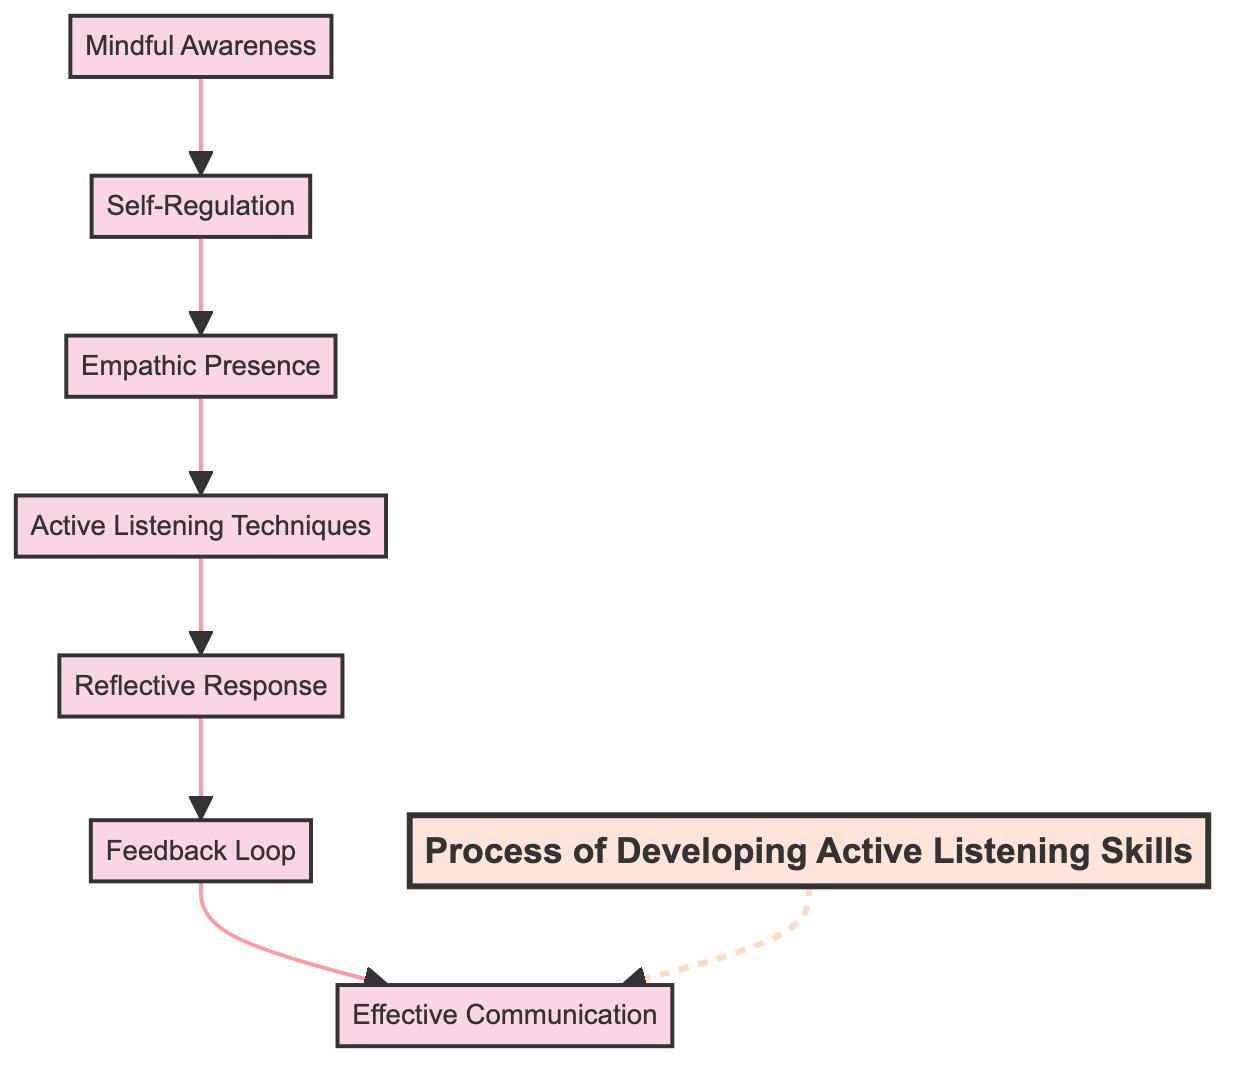What is the starting point of the process? The starting point is "Mindful Awareness," which is the first step in the flowchart.
Answer: Mindful Awareness How many steps are there in the process? There are seven steps depicted in the diagram, ranging from "Mindful Awareness" to "Effective Communication."
Answer: 7 What comes immediately after "Self-Regulation"? The step that comes immediately after "Self-Regulation" is "Empathic Presence."
Answer: Empathic Presence Which step involves reflecting back what the speaker has said? The step involving reflecting back is "Reflective Response." It specifically focuses on confirming understanding with the speaker.
Answer: Reflective Response What element is at the top of the flowchart? The element at the top of the flowchart is "Effective Communication," indicating the final goal of the process.
Answer: Effective Communication What is the relationship between "Active Listening Techniques" and "Feedback Loop"? "Active Listening Techniques" flows directly into "Feedback Loop," indicating that after using techniques, feedback and dialogue follow.
Answer: Direct connection Which step is connected to both "Self-Regulation" and "Active Listening Techniques"? "Empathic Presence" connects "Self-Regulation" with "Active Listening Techniques," showcasing its role in the process.
Answer: Empathic Presence How does the diagram depict the flow of the process? The flowchart depicts the process as a bottom-to-top sequence that indicates progression from mindfulness to effective communication.
Answer: Bottom-to-top sequence 